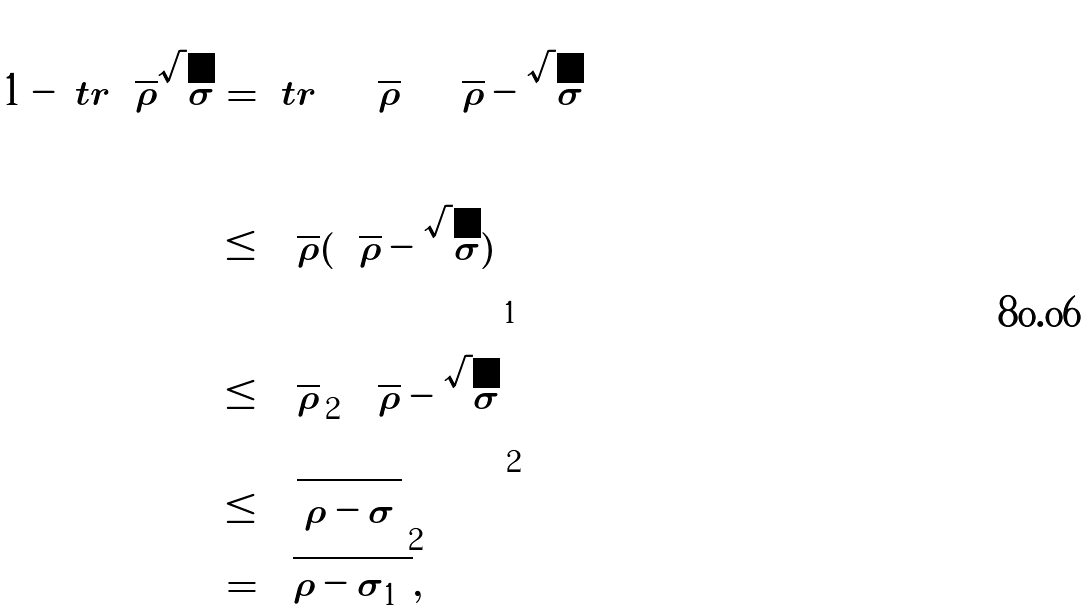Convert formula to latex. <formula><loc_0><loc_0><loc_500><loc_500>1 - \ t r \sqrt { \rho } \sqrt { \sigma } & = \ t r \left ( \sqrt { \rho } \left ( \sqrt { \rho } - \sqrt { \sigma } \right ) \right ) \\ & \leq \left \| \sqrt { \rho } ( \sqrt { \rho } - \sqrt { \sigma } ) \right \| _ { 1 } \\ & \leq \left \| \sqrt { \rho } \right \| _ { 2 } \left \| \sqrt { \rho } - \sqrt { \sigma } \right \| _ { 2 } \\ & \leq \left \| \sqrt { \left | \rho - \sigma \right | } \right \| _ { 2 } \\ & = \sqrt { \| \rho - \sigma \| _ { 1 } } ,</formula> 